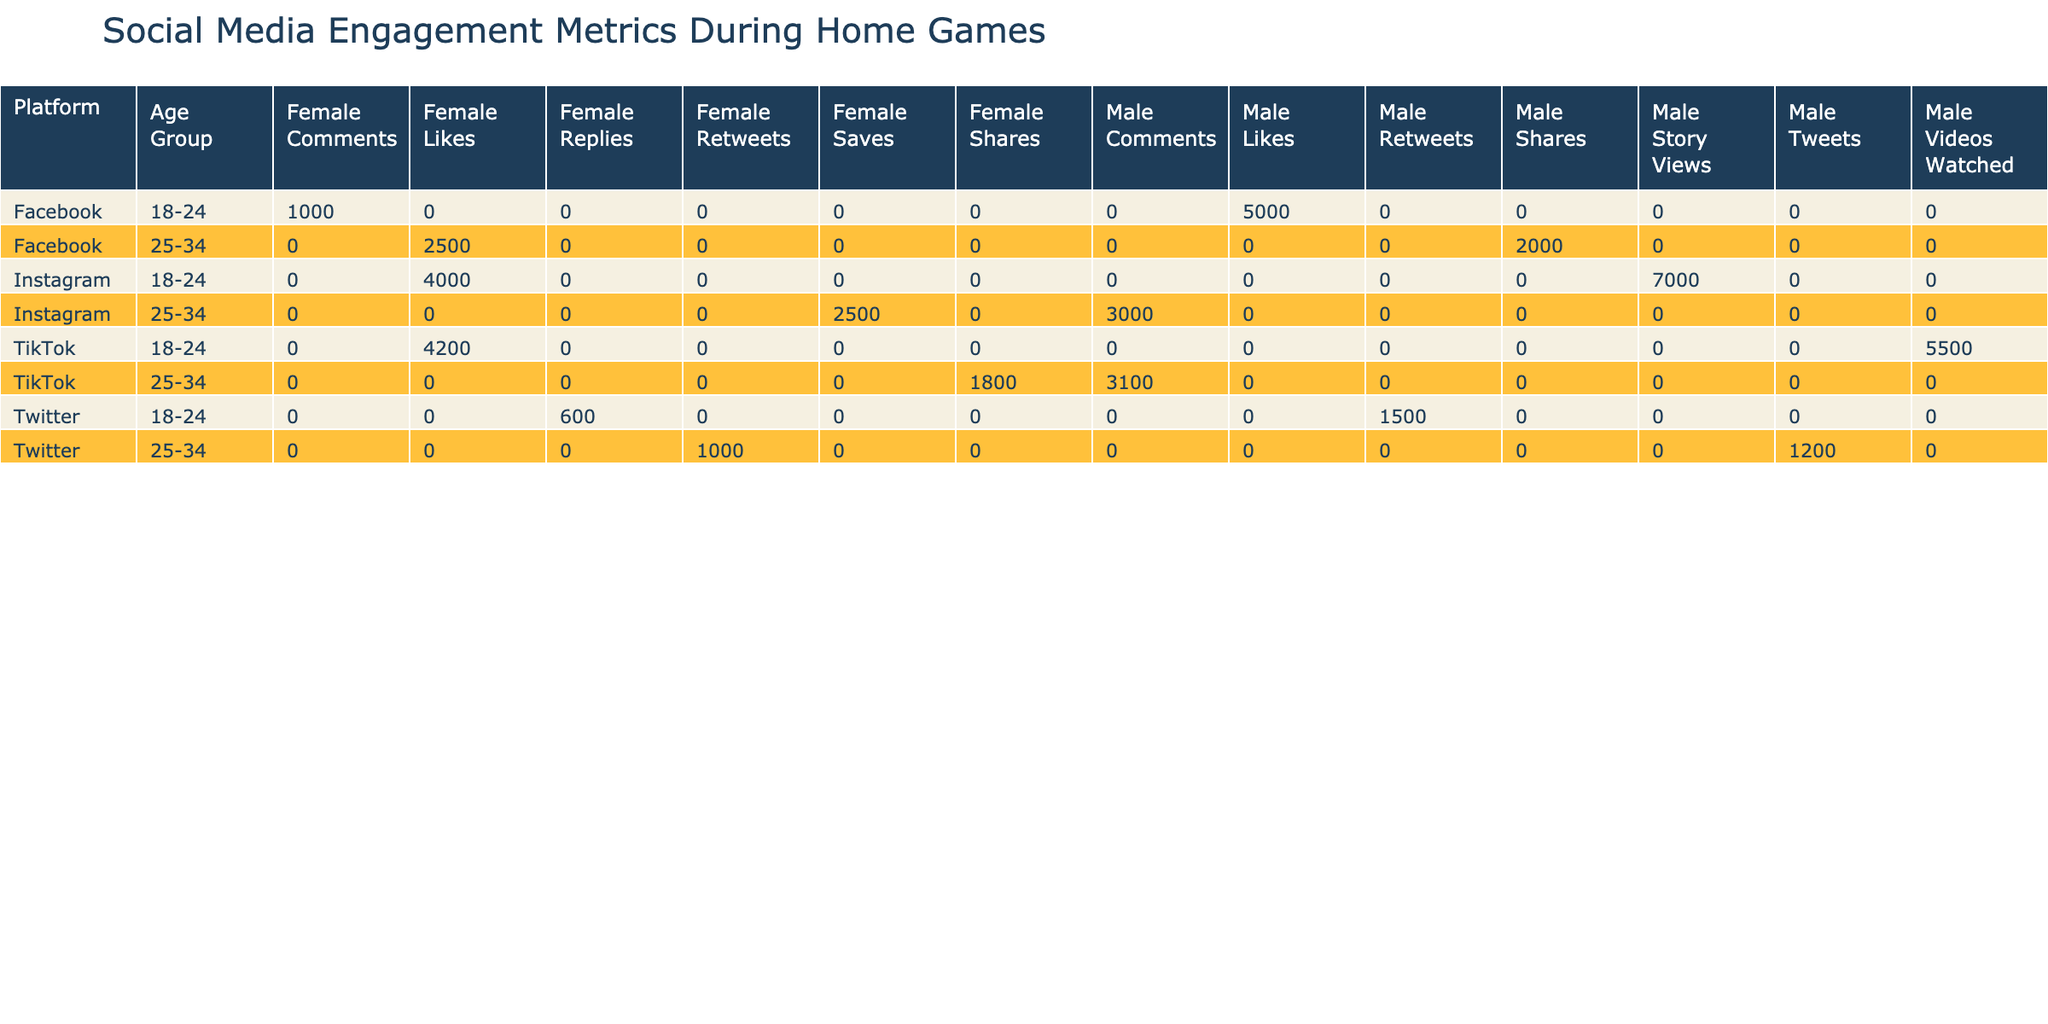What is the total number of impressions for Twitter engagements among 25-34-year-old males? The table shows that for the Twitter platform and the age group 25-34, the only engagement action logged for males is "Tweets" with 1200 impressions. There are no other engagements listed in this category for this demographic. Therefore, the total impressions for Twitter engagements among 25-34-year-old males is 1200.
Answer: 1200 Which platform had the highest number of likes among females aged 18-24? From the table, we look at the likes for females aged 18-24. The only data point for this demographic across all platforms shows 300 likes on Facebook and 1200 likes on Instagram. Comparing these, Instagram has the highest likes for this age group and is the answer.
Answer: Instagram How many total engagement actions were recorded for TikTok among males aged 25-34? The table reveals two engagement actions for males aged 25-34 on TikTok: "Comments" with 900 actions and "Shares" with 500 actions. To find the total, we sum these two values: 900 + 500 = 1400. Therefore, the total engagement actions for TikTok among males aged 25-34 is 1400.
Answer: 1400 Is the number of comments for Instagram engagements among females aged 25-34 greater than the number of likes for TikTok engagements among males aged 18-24? For Instagram, females aged 25-34 have "Saves" with 670 actions and no "Comments" listed, which implies 0 comments in this demographic. For TikTok, males aged 18-24 have "Likes" recorded at 1100 actions. Since 0 is not greater than 1100, the answer is no.
Answer: No What is the average number of impressions for Facebook engagements across all age groups? To calculate the average, we add the total impressions for Facebook engagements across all age groups: 5000 (Males, Likes) + 1000 (Females, Comments) + 2000 (Males, Shares) + 2500 (Females, Likes) = 10500. Since there are 4 entries, the average is 10500 / 4 = 2625.
Answer: 2625 